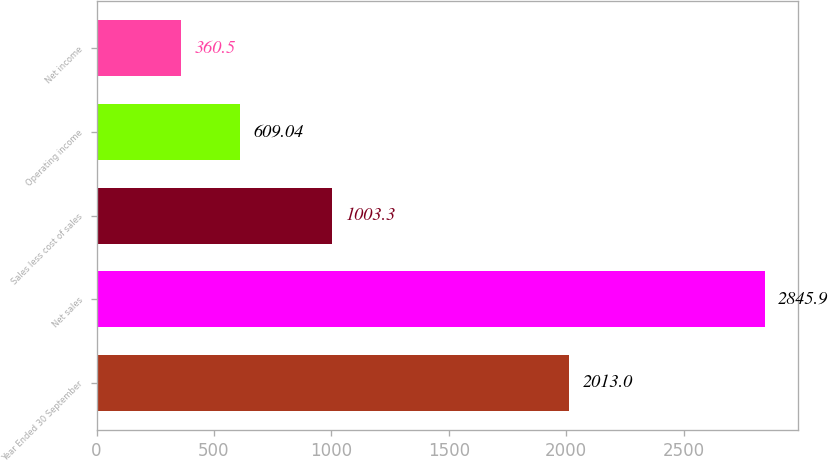<chart> <loc_0><loc_0><loc_500><loc_500><bar_chart><fcel>Year Ended 30 September<fcel>Net sales<fcel>Sales less cost of sales<fcel>Operating income<fcel>Net income<nl><fcel>2013<fcel>2845.9<fcel>1003.3<fcel>609.04<fcel>360.5<nl></chart> 